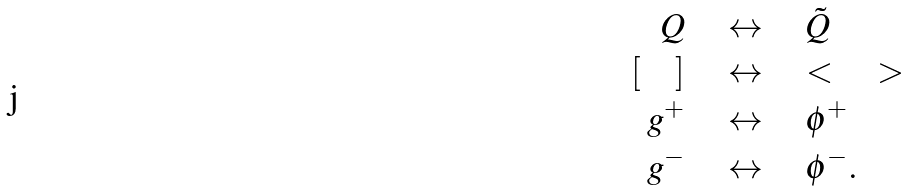<formula> <loc_0><loc_0><loc_500><loc_500>Q \quad & \leftrightarrow \quad \tilde { Q } \\ \left [ \quad \right ] \quad & \leftrightarrow \quad \ < \quad \ > \\ g ^ { + } \quad & \leftrightarrow \quad \phi ^ { + } \\ g ^ { - } \quad & \leftrightarrow \quad \phi ^ { - } .</formula> 